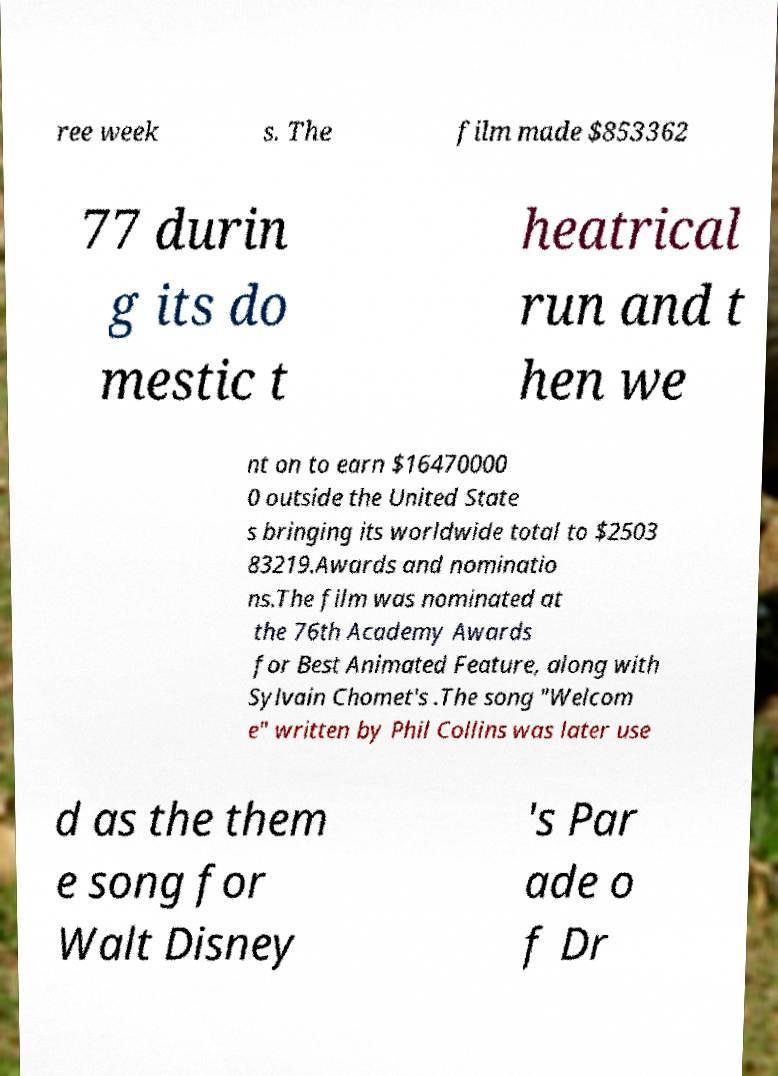Please read and relay the text visible in this image. What does it say? ree week s. The film made $853362 77 durin g its do mestic t heatrical run and t hen we nt on to earn $16470000 0 outside the United State s bringing its worldwide total to $2503 83219.Awards and nominatio ns.The film was nominated at the 76th Academy Awards for Best Animated Feature, along with Sylvain Chomet's .The song "Welcom e" written by Phil Collins was later use d as the them e song for Walt Disney 's Par ade o f Dr 